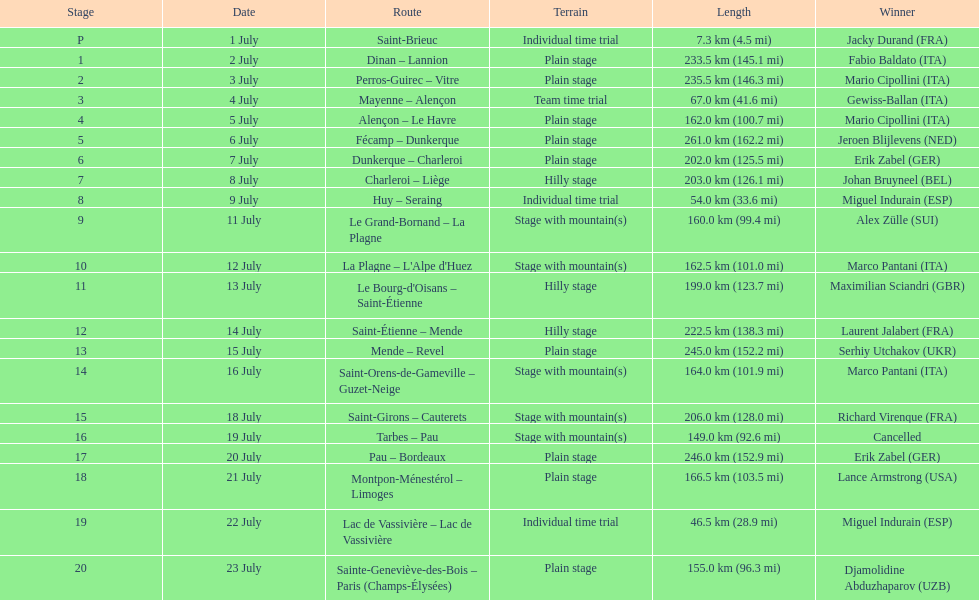After lance armstrong, who took the lead in the 1995 tour de france? Miguel Indurain. 